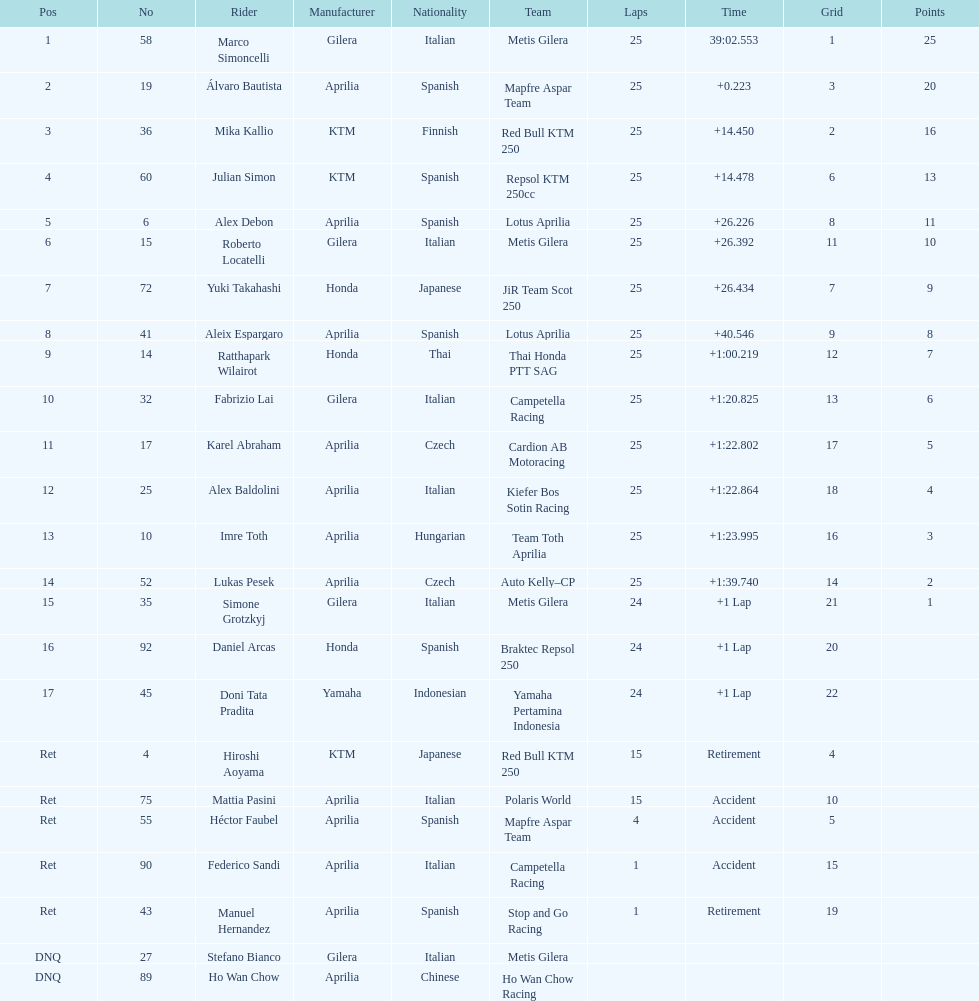What's the total count of laps imre toth has accomplished? 25. 